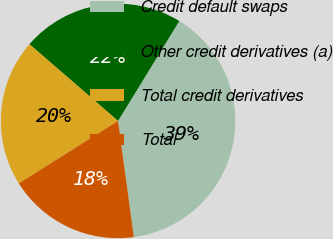<chart> <loc_0><loc_0><loc_500><loc_500><pie_chart><fcel>Credit default swaps<fcel>Other credit derivatives (a)<fcel>Total credit derivatives<fcel>Total<nl><fcel>39.09%<fcel>22.39%<fcel>20.3%<fcel>18.22%<nl></chart> 